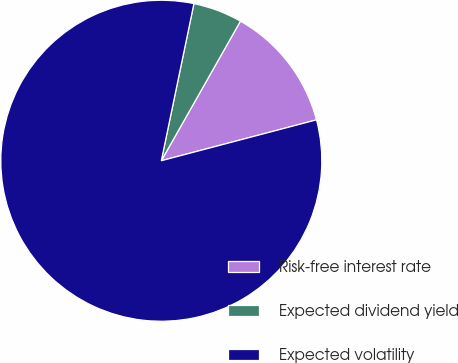<chart> <loc_0><loc_0><loc_500><loc_500><pie_chart><fcel>Risk-free interest rate<fcel>Expected dividend yield<fcel>Expected volatility<nl><fcel>12.69%<fcel>4.95%<fcel>82.35%<nl></chart> 